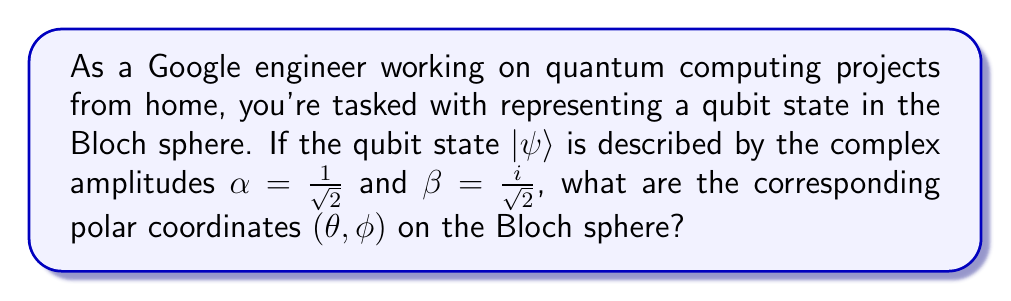Teach me how to tackle this problem. To solve this problem, let's follow these steps:

1) The general form of a qubit state is:
   $$|\psi\rangle = \alpha|0\rangle + \beta|1\rangle$$
   where $\alpha$ and $\beta$ are complex numbers satisfying $|\alpha|^2 + |\beta|^2 = 1$.

2) In the Bloch sphere representation, we can write:
   $$\alpha = \cos(\frac{\theta}{2})$$
   $$\beta = e^{i\phi}\sin(\frac{\theta}{2})$$

3) Given: $\alpha = \frac{1}{\sqrt{2}}$ and $\beta = \frac{i}{\sqrt{2}}$

4) To find $\theta$:
   $$\cos(\frac{\theta}{2}) = \frac{1}{\sqrt{2}}$$
   $$\frac{\theta}{2} = \arccos(\frac{1}{\sqrt{2}}) = \frac{\pi}{4}$$
   $$\theta = \frac{\pi}{2}$$

5) To find $\phi$:
   $$\frac{i}{\sqrt{2}} = e^{i\phi}\sin(\frac{\pi}{4})$$
   $$\frac{i}{\sqrt{2}} = e^{i\phi}\frac{1}{\sqrt{2}}$$
   $$i = e^{i\phi}$$
   $$\phi = \frac{\pi}{2}$$

Therefore, the polar coordinates on the Bloch sphere are $(\frac{\pi}{2}, \frac{\pi}{2})$.
Answer: $(\frac{\pi}{2}, \frac{\pi}{2})$ 